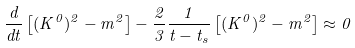Convert formula to latex. <formula><loc_0><loc_0><loc_500><loc_500>\frac { d } { d t } \left [ ( K ^ { 0 } ) ^ { 2 } - m ^ { 2 } \right ] - \frac { 2 } { 3 } \frac { 1 } { t - t _ { s } } \left [ ( K ^ { 0 } ) ^ { 2 } - m ^ { 2 } \right ] \approx 0</formula> 